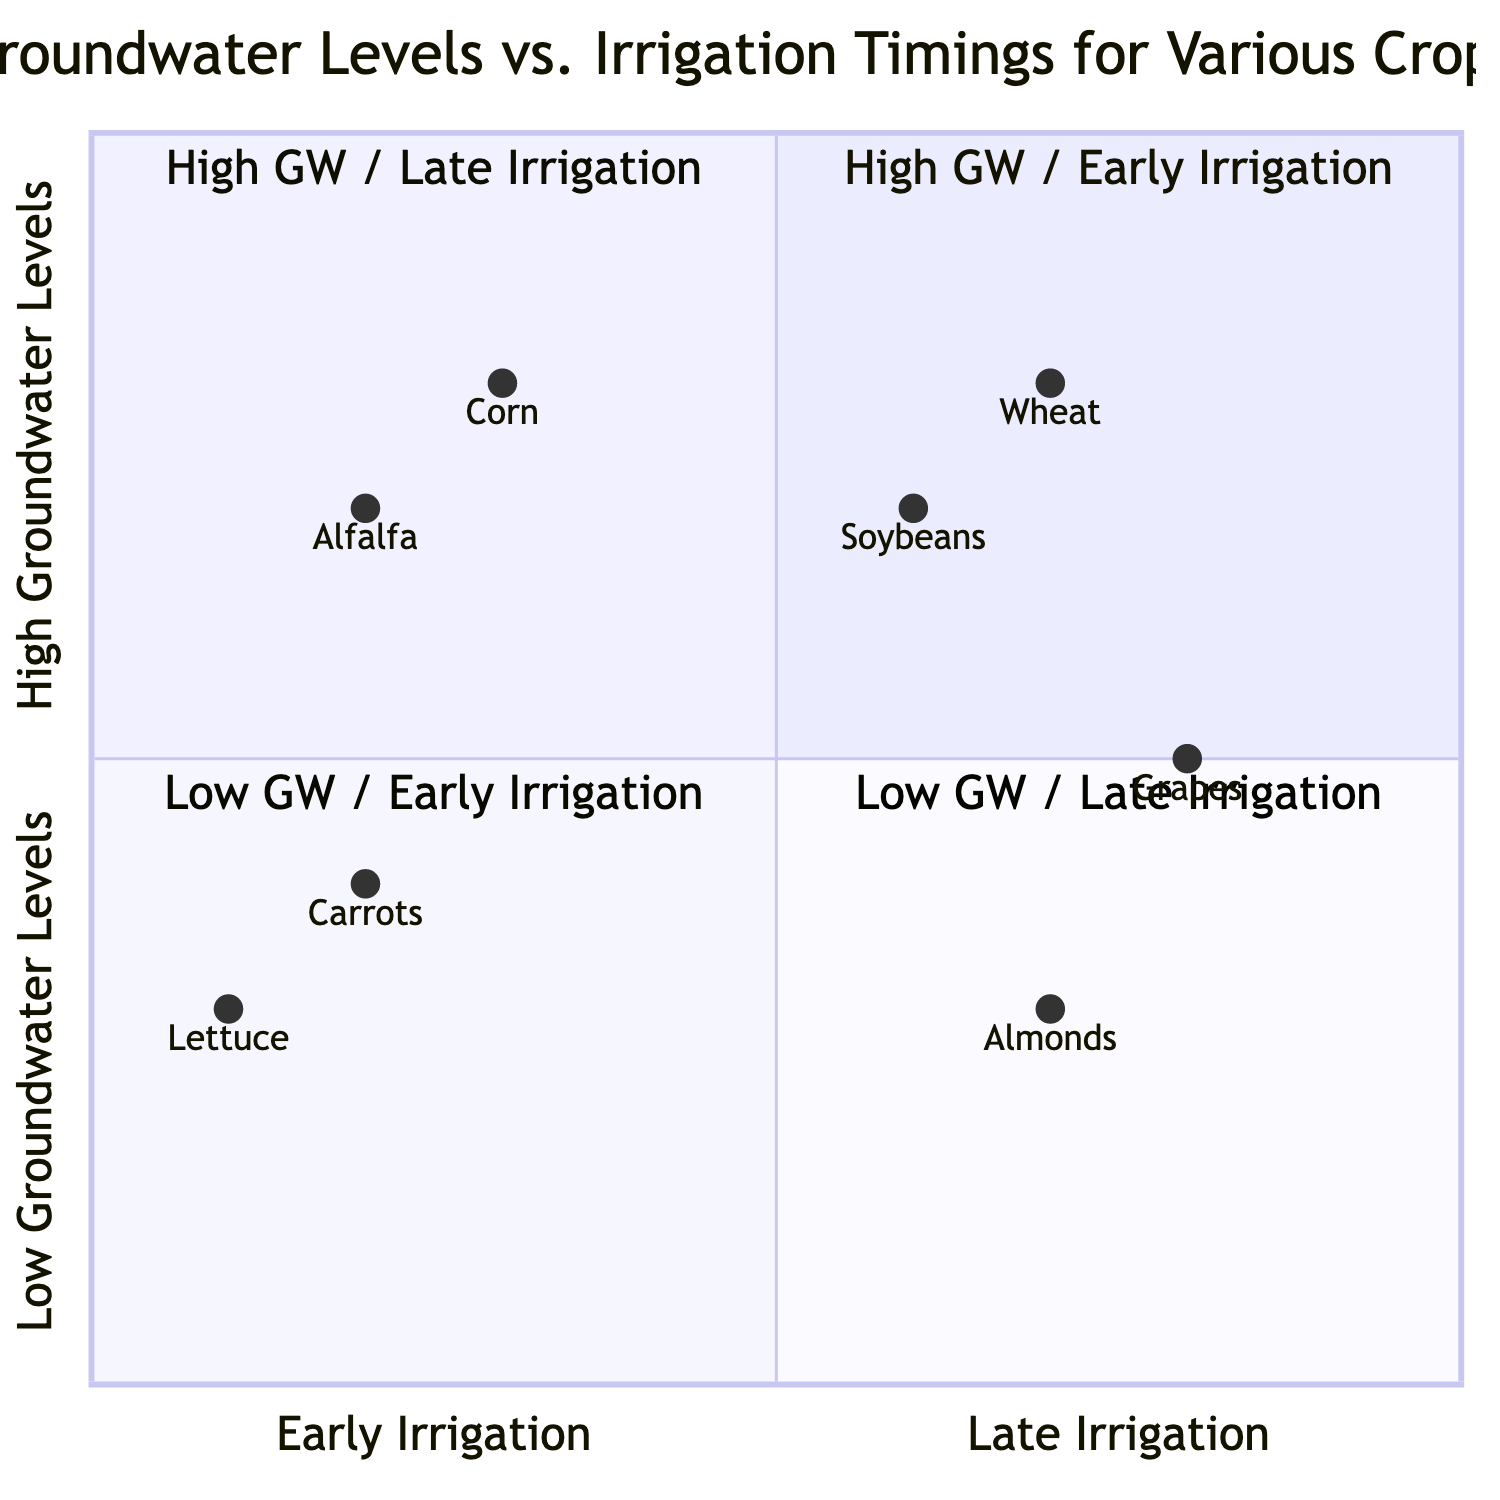What crops are found in the "High Groundwater Levels / Early Irrigation Timings" quadrant? In the quadrant labeled "High Groundwater Levels / Early Irrigation Timings," the crops listed are Corn and Alfalfa.
Answer: Corn, Alfalfa Which crop has the latest optimal irrigation timing in the "Low Groundwater Levels / Late Irrigation Timings" quadrant? In this quadrant, Almonds have an optimal irrigation timing of September - October, which is later than Grapes’ timing of September - November.
Answer: Almonds What is the groundwater level range for Lettuce? The data indicates that Lettuce has a groundwater level range of 30-35 feet.
Answer: 30-35 feet How many crops are there in the "Low Groundwater Levels / Early Irrigation Timings" quadrant? Within the "Low Groundwater Levels / Early Irrigation Timings" quadrant, there are two crops: Lettuce and Carrots.
Answer: 2 Which crop has the earliest irrigation timing in the "High Groundwater Levels / Late Irrigation Timings" quadrant? In this quadrant, Wheat has the earliest irrigation timing of August - October compared to Soybeans’ timing of July - September.
Answer: Wheat What is the optimal irrigation timing for Alfalfa? The optimal irrigation timing for Alfalfa is April - June.
Answer: April - June Which quadrant contains crops that require low groundwater levels? The "Low Groundwater Levels / Early Irrigation Timings" and "Low Groundwater Levels / Late Irrigation Timings" quadrants contain crops that require low groundwater levels.
Answer: Low Groundwater Levels / Early Irrigation Timings, Low Groundwater Levels / Late Irrigation Timings How does the groundwater level for Corn compare to that of Carrots? Corn has a groundwater level of 15-20 feet, while Carrots have a higher groundwater level of 25-30 feet.
Answer: Corn: 15-20 feet, Carrots: 25-30 feet Which crop has the highest groundwater level requirement? The highest groundwater level requirement, at 30-35 feet, is associated with Lettuce and Almonds.
Answer: Lettuce, Almonds 